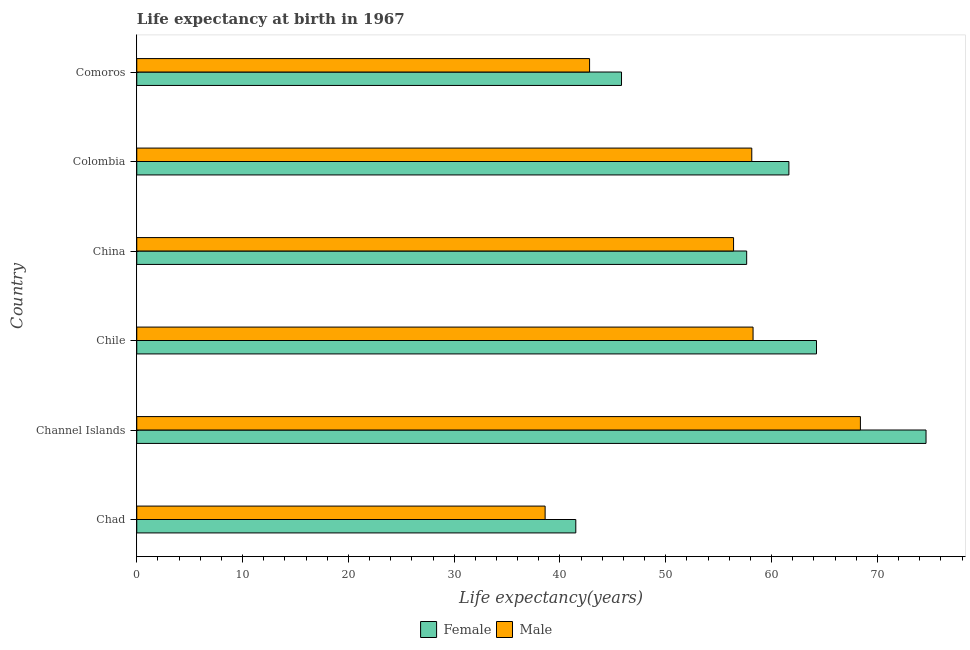Are the number of bars per tick equal to the number of legend labels?
Your answer should be very brief. Yes. What is the label of the 5th group of bars from the top?
Make the answer very short. Channel Islands. What is the life expectancy(female) in Colombia?
Keep it short and to the point. 61.64. Across all countries, what is the maximum life expectancy(male)?
Give a very brief answer. 68.4. Across all countries, what is the minimum life expectancy(female)?
Make the answer very short. 41.5. In which country was the life expectancy(male) maximum?
Your answer should be compact. Channel Islands. In which country was the life expectancy(female) minimum?
Your answer should be compact. Chad. What is the total life expectancy(male) in the graph?
Ensure brevity in your answer.  322.58. What is the difference between the life expectancy(female) in China and that in Comoros?
Provide a succinct answer. 11.83. What is the difference between the life expectancy(female) in Comoros and the life expectancy(male) in Chile?
Offer a very short reply. -12.43. What is the average life expectancy(male) per country?
Make the answer very short. 53.76. What is the difference between the life expectancy(female) and life expectancy(male) in China?
Provide a succinct answer. 1.24. In how many countries, is the life expectancy(male) greater than 8 years?
Give a very brief answer. 6. What is the ratio of the life expectancy(male) in Channel Islands to that in Comoros?
Make the answer very short. 1.6. Is the life expectancy(female) in Channel Islands less than that in Colombia?
Offer a terse response. No. What is the difference between the highest and the second highest life expectancy(female)?
Your response must be concise. 10.35. What is the difference between the highest and the lowest life expectancy(male)?
Give a very brief answer. 29.8. In how many countries, is the life expectancy(male) greater than the average life expectancy(male) taken over all countries?
Make the answer very short. 4. Is the sum of the life expectancy(male) in Chile and Colombia greater than the maximum life expectancy(female) across all countries?
Offer a very short reply. Yes. What does the 1st bar from the bottom in Chile represents?
Offer a terse response. Female. Are all the bars in the graph horizontal?
Make the answer very short. Yes. What is the difference between two consecutive major ticks on the X-axis?
Keep it short and to the point. 10. Are the values on the major ticks of X-axis written in scientific E-notation?
Ensure brevity in your answer.  No. Does the graph contain any zero values?
Offer a very short reply. No. Where does the legend appear in the graph?
Offer a very short reply. Bottom center. What is the title of the graph?
Give a very brief answer. Life expectancy at birth in 1967. What is the label or title of the X-axis?
Offer a very short reply. Life expectancy(years). What is the label or title of the Y-axis?
Offer a very short reply. Country. What is the Life expectancy(years) in Female in Chad?
Ensure brevity in your answer.  41.5. What is the Life expectancy(years) in Male in Chad?
Your answer should be compact. 38.6. What is the Life expectancy(years) of Female in Channel Islands?
Provide a short and direct response. 74.6. What is the Life expectancy(years) in Male in Channel Islands?
Provide a short and direct response. 68.4. What is the Life expectancy(years) of Female in Chile?
Your answer should be compact. 64.25. What is the Life expectancy(years) of Male in Chile?
Give a very brief answer. 58.25. What is the Life expectancy(years) in Female in China?
Make the answer very short. 57.65. What is the Life expectancy(years) in Male in China?
Make the answer very short. 56.41. What is the Life expectancy(years) in Female in Colombia?
Give a very brief answer. 61.64. What is the Life expectancy(years) in Male in Colombia?
Keep it short and to the point. 58.13. What is the Life expectancy(years) of Female in Comoros?
Offer a very short reply. 45.82. What is the Life expectancy(years) of Male in Comoros?
Offer a terse response. 42.8. Across all countries, what is the maximum Life expectancy(years) of Female?
Offer a terse response. 74.6. Across all countries, what is the maximum Life expectancy(years) in Male?
Offer a very short reply. 68.4. Across all countries, what is the minimum Life expectancy(years) of Female?
Your response must be concise. 41.5. Across all countries, what is the minimum Life expectancy(years) in Male?
Make the answer very short. 38.6. What is the total Life expectancy(years) of Female in the graph?
Your answer should be compact. 345.44. What is the total Life expectancy(years) in Male in the graph?
Your answer should be very brief. 322.58. What is the difference between the Life expectancy(years) of Female in Chad and that in Channel Islands?
Your answer should be very brief. -33.1. What is the difference between the Life expectancy(years) in Male in Chad and that in Channel Islands?
Give a very brief answer. -29.8. What is the difference between the Life expectancy(years) in Female in Chad and that in Chile?
Your answer should be compact. -22.75. What is the difference between the Life expectancy(years) of Male in Chad and that in Chile?
Offer a very short reply. -19.65. What is the difference between the Life expectancy(years) of Female in Chad and that in China?
Your answer should be very brief. -16.15. What is the difference between the Life expectancy(years) of Male in Chad and that in China?
Your response must be concise. -17.81. What is the difference between the Life expectancy(years) of Female in Chad and that in Colombia?
Make the answer very short. -20.14. What is the difference between the Life expectancy(years) of Male in Chad and that in Colombia?
Your answer should be very brief. -19.53. What is the difference between the Life expectancy(years) of Female in Chad and that in Comoros?
Provide a succinct answer. -4.32. What is the difference between the Life expectancy(years) of Male in Chad and that in Comoros?
Offer a very short reply. -4.2. What is the difference between the Life expectancy(years) in Female in Channel Islands and that in Chile?
Give a very brief answer. 10.35. What is the difference between the Life expectancy(years) in Male in Channel Islands and that in Chile?
Your answer should be compact. 10.14. What is the difference between the Life expectancy(years) in Female in Channel Islands and that in China?
Offer a terse response. 16.95. What is the difference between the Life expectancy(years) in Male in Channel Islands and that in China?
Offer a terse response. 11.99. What is the difference between the Life expectancy(years) of Female in Channel Islands and that in Colombia?
Keep it short and to the point. 12.96. What is the difference between the Life expectancy(years) in Male in Channel Islands and that in Colombia?
Offer a very short reply. 10.27. What is the difference between the Life expectancy(years) of Female in Channel Islands and that in Comoros?
Your answer should be compact. 28.78. What is the difference between the Life expectancy(years) in Male in Channel Islands and that in Comoros?
Your response must be concise. 25.6. What is the difference between the Life expectancy(years) of Female in Chile and that in China?
Make the answer very short. 6.6. What is the difference between the Life expectancy(years) of Male in Chile and that in China?
Keep it short and to the point. 1.84. What is the difference between the Life expectancy(years) in Female in Chile and that in Colombia?
Your answer should be very brief. 2.61. What is the difference between the Life expectancy(years) of Male in Chile and that in Colombia?
Ensure brevity in your answer.  0.12. What is the difference between the Life expectancy(years) of Female in Chile and that in Comoros?
Make the answer very short. 18.43. What is the difference between the Life expectancy(years) in Male in Chile and that in Comoros?
Your answer should be very brief. 15.45. What is the difference between the Life expectancy(years) of Female in China and that in Colombia?
Offer a terse response. -3.99. What is the difference between the Life expectancy(years) in Male in China and that in Colombia?
Provide a succinct answer. -1.72. What is the difference between the Life expectancy(years) in Female in China and that in Comoros?
Offer a very short reply. 11.83. What is the difference between the Life expectancy(years) in Male in China and that in Comoros?
Provide a short and direct response. 13.61. What is the difference between the Life expectancy(years) of Female in Colombia and that in Comoros?
Your answer should be compact. 15.82. What is the difference between the Life expectancy(years) of Male in Colombia and that in Comoros?
Provide a short and direct response. 15.33. What is the difference between the Life expectancy(years) of Female in Chad and the Life expectancy(years) of Male in Channel Islands?
Offer a very short reply. -26.9. What is the difference between the Life expectancy(years) in Female in Chad and the Life expectancy(years) in Male in Chile?
Your answer should be very brief. -16.75. What is the difference between the Life expectancy(years) of Female in Chad and the Life expectancy(years) of Male in China?
Give a very brief answer. -14.91. What is the difference between the Life expectancy(years) in Female in Chad and the Life expectancy(years) in Male in Colombia?
Provide a short and direct response. -16.63. What is the difference between the Life expectancy(years) in Female in Chad and the Life expectancy(years) in Male in Comoros?
Your response must be concise. -1.3. What is the difference between the Life expectancy(years) in Female in Channel Islands and the Life expectancy(years) in Male in Chile?
Give a very brief answer. 16.35. What is the difference between the Life expectancy(years) of Female in Channel Islands and the Life expectancy(years) of Male in China?
Offer a terse response. 18.19. What is the difference between the Life expectancy(years) in Female in Channel Islands and the Life expectancy(years) in Male in Colombia?
Your response must be concise. 16.47. What is the difference between the Life expectancy(years) in Female in Channel Islands and the Life expectancy(years) in Male in Comoros?
Make the answer very short. 31.8. What is the difference between the Life expectancy(years) in Female in Chile and the Life expectancy(years) in Male in China?
Offer a very short reply. 7.84. What is the difference between the Life expectancy(years) of Female in Chile and the Life expectancy(years) of Male in Colombia?
Your answer should be very brief. 6.12. What is the difference between the Life expectancy(years) in Female in Chile and the Life expectancy(years) in Male in Comoros?
Offer a terse response. 21.45. What is the difference between the Life expectancy(years) of Female in China and the Life expectancy(years) of Male in Colombia?
Make the answer very short. -0.48. What is the difference between the Life expectancy(years) of Female in China and the Life expectancy(years) of Male in Comoros?
Offer a terse response. 14.85. What is the difference between the Life expectancy(years) of Female in Colombia and the Life expectancy(years) of Male in Comoros?
Keep it short and to the point. 18.84. What is the average Life expectancy(years) in Female per country?
Provide a short and direct response. 57.57. What is the average Life expectancy(years) of Male per country?
Your answer should be very brief. 53.76. What is the difference between the Life expectancy(years) of Female and Life expectancy(years) of Male in Chad?
Provide a short and direct response. 2.9. What is the difference between the Life expectancy(years) of Female and Life expectancy(years) of Male in Channel Islands?
Your answer should be very brief. 6.2. What is the difference between the Life expectancy(years) of Female and Life expectancy(years) of Male in Chile?
Make the answer very short. 6. What is the difference between the Life expectancy(years) of Female and Life expectancy(years) of Male in China?
Your answer should be very brief. 1.24. What is the difference between the Life expectancy(years) of Female and Life expectancy(years) of Male in Colombia?
Keep it short and to the point. 3.51. What is the difference between the Life expectancy(years) of Female and Life expectancy(years) of Male in Comoros?
Provide a succinct answer. 3.02. What is the ratio of the Life expectancy(years) in Female in Chad to that in Channel Islands?
Offer a very short reply. 0.56. What is the ratio of the Life expectancy(years) in Male in Chad to that in Channel Islands?
Make the answer very short. 0.56. What is the ratio of the Life expectancy(years) in Female in Chad to that in Chile?
Ensure brevity in your answer.  0.65. What is the ratio of the Life expectancy(years) of Male in Chad to that in Chile?
Your response must be concise. 0.66. What is the ratio of the Life expectancy(years) of Female in Chad to that in China?
Your answer should be very brief. 0.72. What is the ratio of the Life expectancy(years) in Male in Chad to that in China?
Your response must be concise. 0.68. What is the ratio of the Life expectancy(years) of Female in Chad to that in Colombia?
Ensure brevity in your answer.  0.67. What is the ratio of the Life expectancy(years) of Male in Chad to that in Colombia?
Make the answer very short. 0.66. What is the ratio of the Life expectancy(years) in Female in Chad to that in Comoros?
Offer a terse response. 0.91. What is the ratio of the Life expectancy(years) of Male in Chad to that in Comoros?
Give a very brief answer. 0.9. What is the ratio of the Life expectancy(years) of Female in Channel Islands to that in Chile?
Your answer should be compact. 1.16. What is the ratio of the Life expectancy(years) in Male in Channel Islands to that in Chile?
Provide a succinct answer. 1.17. What is the ratio of the Life expectancy(years) of Female in Channel Islands to that in China?
Ensure brevity in your answer.  1.29. What is the ratio of the Life expectancy(years) of Male in Channel Islands to that in China?
Your answer should be compact. 1.21. What is the ratio of the Life expectancy(years) of Female in Channel Islands to that in Colombia?
Make the answer very short. 1.21. What is the ratio of the Life expectancy(years) in Male in Channel Islands to that in Colombia?
Your answer should be very brief. 1.18. What is the ratio of the Life expectancy(years) of Female in Channel Islands to that in Comoros?
Make the answer very short. 1.63. What is the ratio of the Life expectancy(years) of Male in Channel Islands to that in Comoros?
Your answer should be very brief. 1.6. What is the ratio of the Life expectancy(years) of Female in Chile to that in China?
Your answer should be very brief. 1.11. What is the ratio of the Life expectancy(years) of Male in Chile to that in China?
Provide a short and direct response. 1.03. What is the ratio of the Life expectancy(years) in Female in Chile to that in Colombia?
Offer a very short reply. 1.04. What is the ratio of the Life expectancy(years) of Female in Chile to that in Comoros?
Your answer should be compact. 1.4. What is the ratio of the Life expectancy(years) of Male in Chile to that in Comoros?
Offer a terse response. 1.36. What is the ratio of the Life expectancy(years) of Female in China to that in Colombia?
Offer a terse response. 0.94. What is the ratio of the Life expectancy(years) of Male in China to that in Colombia?
Provide a short and direct response. 0.97. What is the ratio of the Life expectancy(years) of Female in China to that in Comoros?
Your answer should be compact. 1.26. What is the ratio of the Life expectancy(years) of Male in China to that in Comoros?
Ensure brevity in your answer.  1.32. What is the ratio of the Life expectancy(years) in Female in Colombia to that in Comoros?
Your answer should be very brief. 1.35. What is the ratio of the Life expectancy(years) in Male in Colombia to that in Comoros?
Make the answer very short. 1.36. What is the difference between the highest and the second highest Life expectancy(years) of Female?
Offer a very short reply. 10.35. What is the difference between the highest and the second highest Life expectancy(years) in Male?
Your response must be concise. 10.14. What is the difference between the highest and the lowest Life expectancy(years) in Female?
Make the answer very short. 33.1. What is the difference between the highest and the lowest Life expectancy(years) of Male?
Your answer should be very brief. 29.8. 